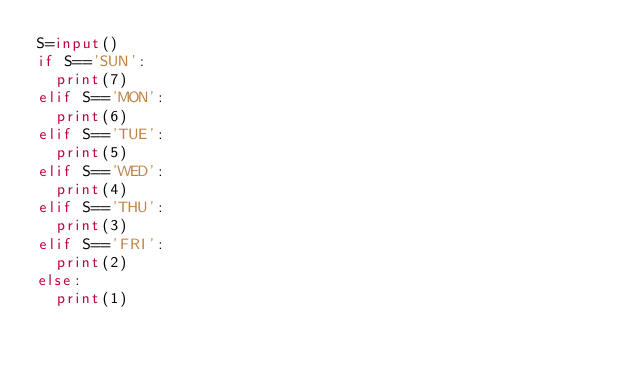Convert code to text. <code><loc_0><loc_0><loc_500><loc_500><_Python_>S=input()
if S=='SUN':
  print(7)
elif S=='MON':
  print(6)
elif S=='TUE':
  print(5)
elif S=='WED':
  print(4)
elif S=='THU':
  print(3)
elif S=='FRI':
  print(2)
else:
  print(1)</code> 